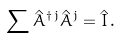<formula> <loc_0><loc_0><loc_500><loc_500>\sum \hat { A } ^ { \dagger \, j } \hat { A } ^ { j } = { \hat { I } } \, .</formula> 